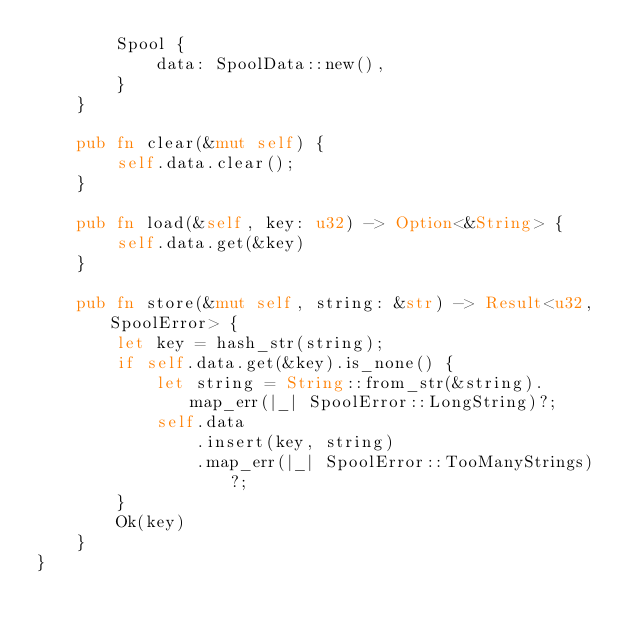Convert code to text. <code><loc_0><loc_0><loc_500><loc_500><_Rust_>        Spool {
            data: SpoolData::new(),
        }
    }

    pub fn clear(&mut self) {
        self.data.clear();
    }

    pub fn load(&self, key: u32) -> Option<&String> {
        self.data.get(&key)
    }

    pub fn store(&mut self, string: &str) -> Result<u32, SpoolError> {
        let key = hash_str(string);
        if self.data.get(&key).is_none() {
            let string = String::from_str(&string).map_err(|_| SpoolError::LongString)?;
            self.data
                .insert(key, string)
                .map_err(|_| SpoolError::TooManyStrings)?;
        }
        Ok(key)
    }
}
</code> 